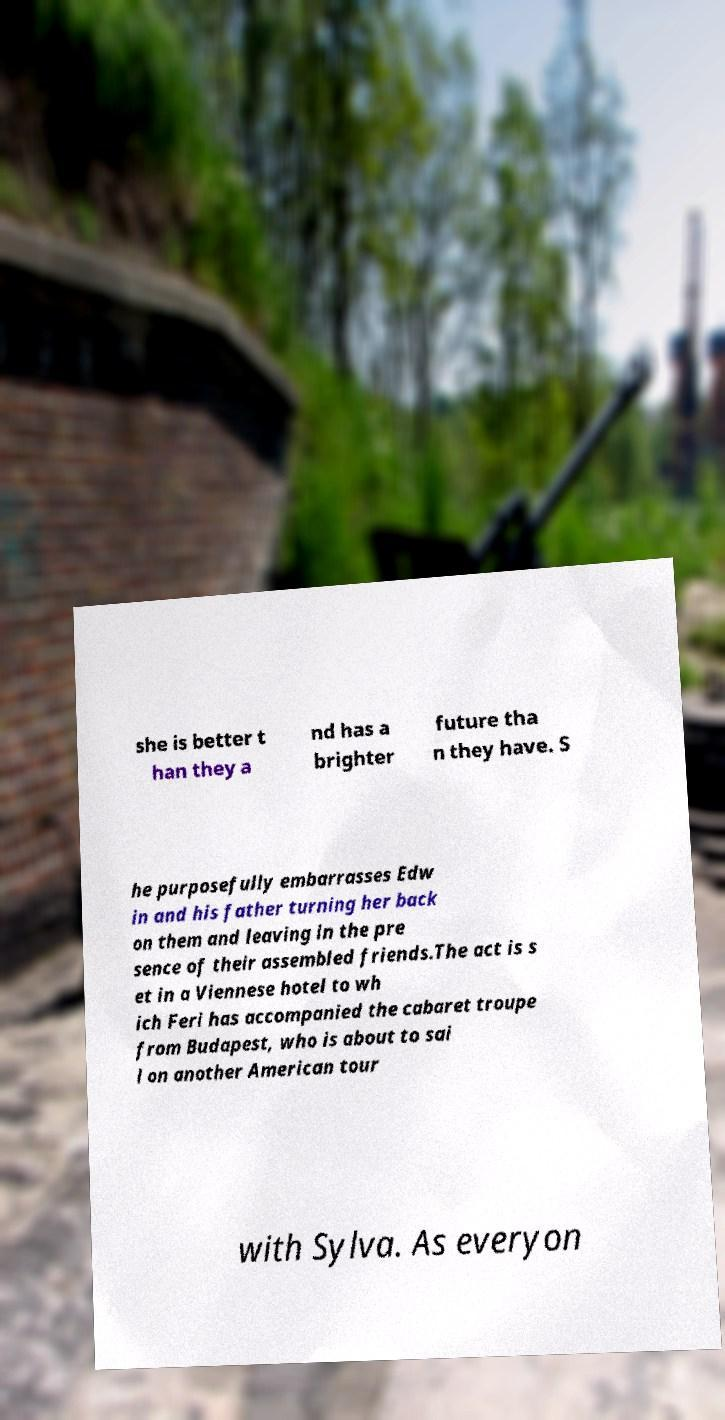Can you accurately transcribe the text from the provided image for me? she is better t han they a nd has a brighter future tha n they have. S he purposefully embarrasses Edw in and his father turning her back on them and leaving in the pre sence of their assembled friends.The act is s et in a Viennese hotel to wh ich Feri has accompanied the cabaret troupe from Budapest, who is about to sai l on another American tour with Sylva. As everyon 